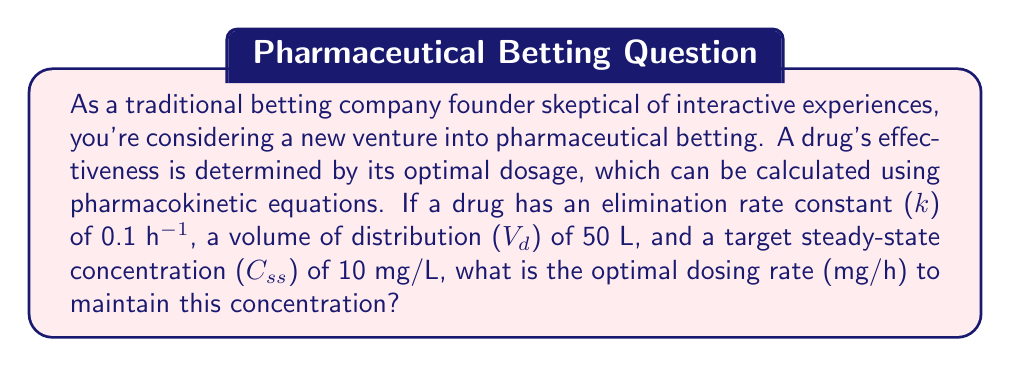What is the answer to this math problem? To solve this problem, we'll use the pharmacokinetic equation for calculating the dosing rate at steady state:

$$ R_{ss} = C_{ss} \cdot CL $$

Where:
$R_{ss}$ is the steady-state dosing rate (mg/h)
$C_{ss}$ is the target steady-state concentration (mg/L)
$CL$ is the clearance (L/h)

We need to calculate the clearance ($CL$) using the given elimination rate constant ($k$) and volume of distribution ($V_d$):

$$ CL = k \cdot V_d $$

Step 1: Calculate the clearance
$$ CL = 0.1 \text{ h}^{-1} \cdot 50 \text{ L} = 5 \text{ L/h} $$

Step 2: Use the steady-state dosing rate equation
$$ R_{ss} = C_{ss} \cdot CL $$
$$ R_{ss} = 10 \text{ mg/L} \cdot 5 \text{ L/h} $$
$$ R_{ss} = 50 \text{ mg/h} $$

Therefore, the optimal dosing rate to maintain the target steady-state concentration is 50 mg/h.
Answer: 50 mg/h 